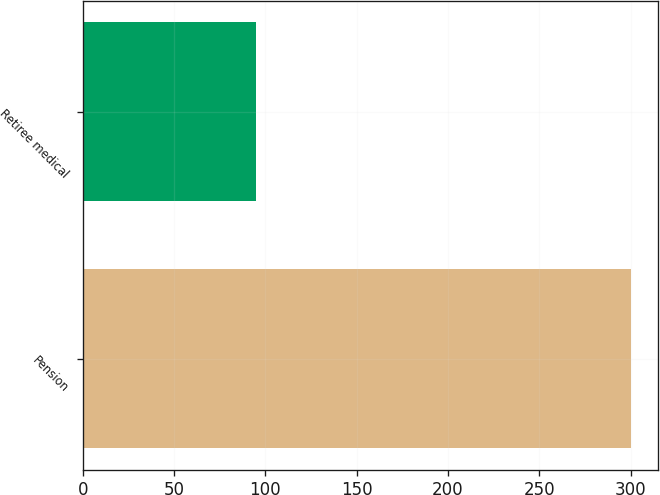Convert chart. <chart><loc_0><loc_0><loc_500><loc_500><bar_chart><fcel>Pension<fcel>Retiree medical<nl><fcel>300<fcel>95<nl></chart> 